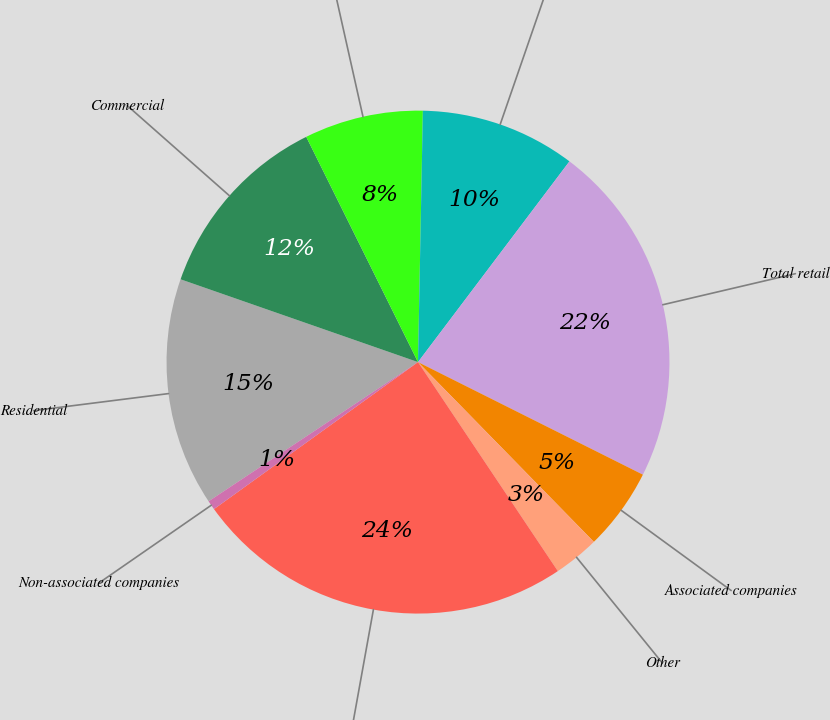Convert chart to OTSL. <chart><loc_0><loc_0><loc_500><loc_500><pie_chart><fcel>Residential<fcel>Commercial<fcel>Industrial<fcel>Governmental<fcel>Total retail<fcel>Associated companies<fcel>Other<fcel>Total<fcel>Non-associated companies<nl><fcel>14.68%<fcel>12.33%<fcel>7.64%<fcel>9.98%<fcel>22.1%<fcel>5.29%<fcel>2.94%<fcel>24.45%<fcel>0.6%<nl></chart> 